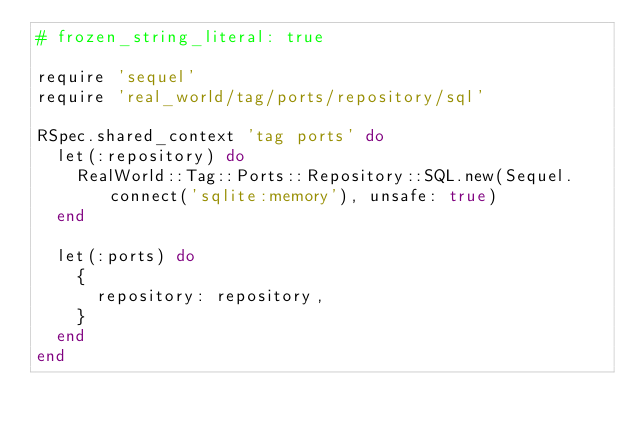<code> <loc_0><loc_0><loc_500><loc_500><_Ruby_># frozen_string_literal: true

require 'sequel'
require 'real_world/tag/ports/repository/sql'

RSpec.shared_context 'tag ports' do
  let(:repository) do
    RealWorld::Tag::Ports::Repository::SQL.new(Sequel.connect('sqlite:memory'), unsafe: true)
  end

  let(:ports) do
    {
      repository: repository,
    }
  end
end
</code> 